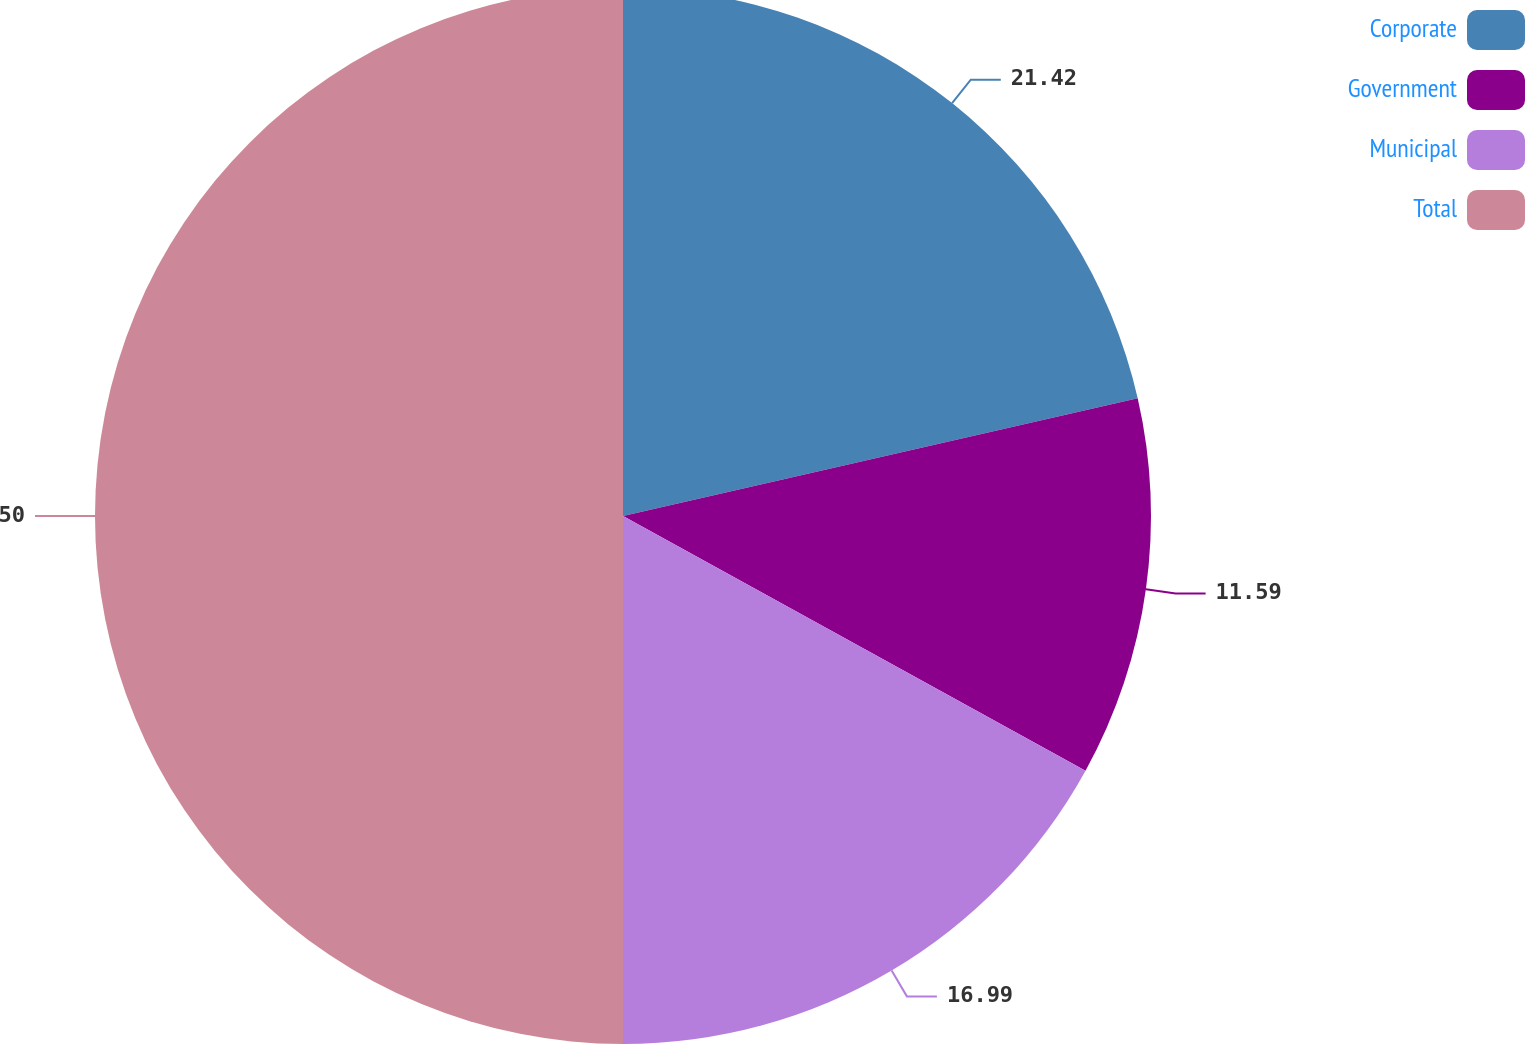<chart> <loc_0><loc_0><loc_500><loc_500><pie_chart><fcel>Corporate<fcel>Government<fcel>Municipal<fcel>Total<nl><fcel>21.42%<fcel>11.59%<fcel>16.99%<fcel>50.0%<nl></chart> 